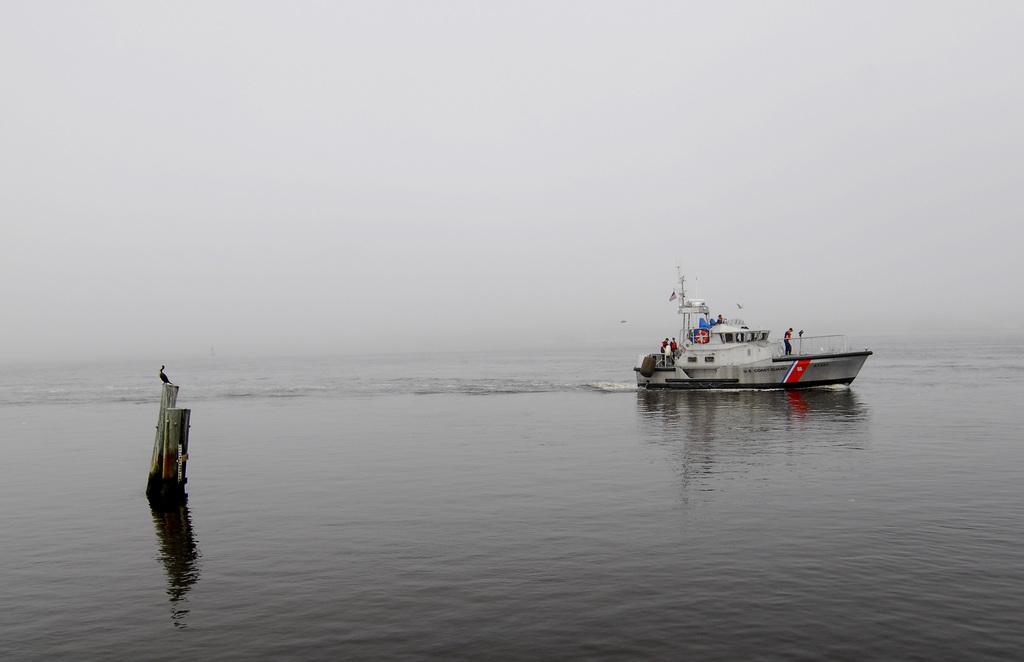Could you give a brief overview of what you see in this image? In this image, we can see few people are sailing a boat on the water. Here we can see poles. There is a bird on the pole. Background there is a sky. 